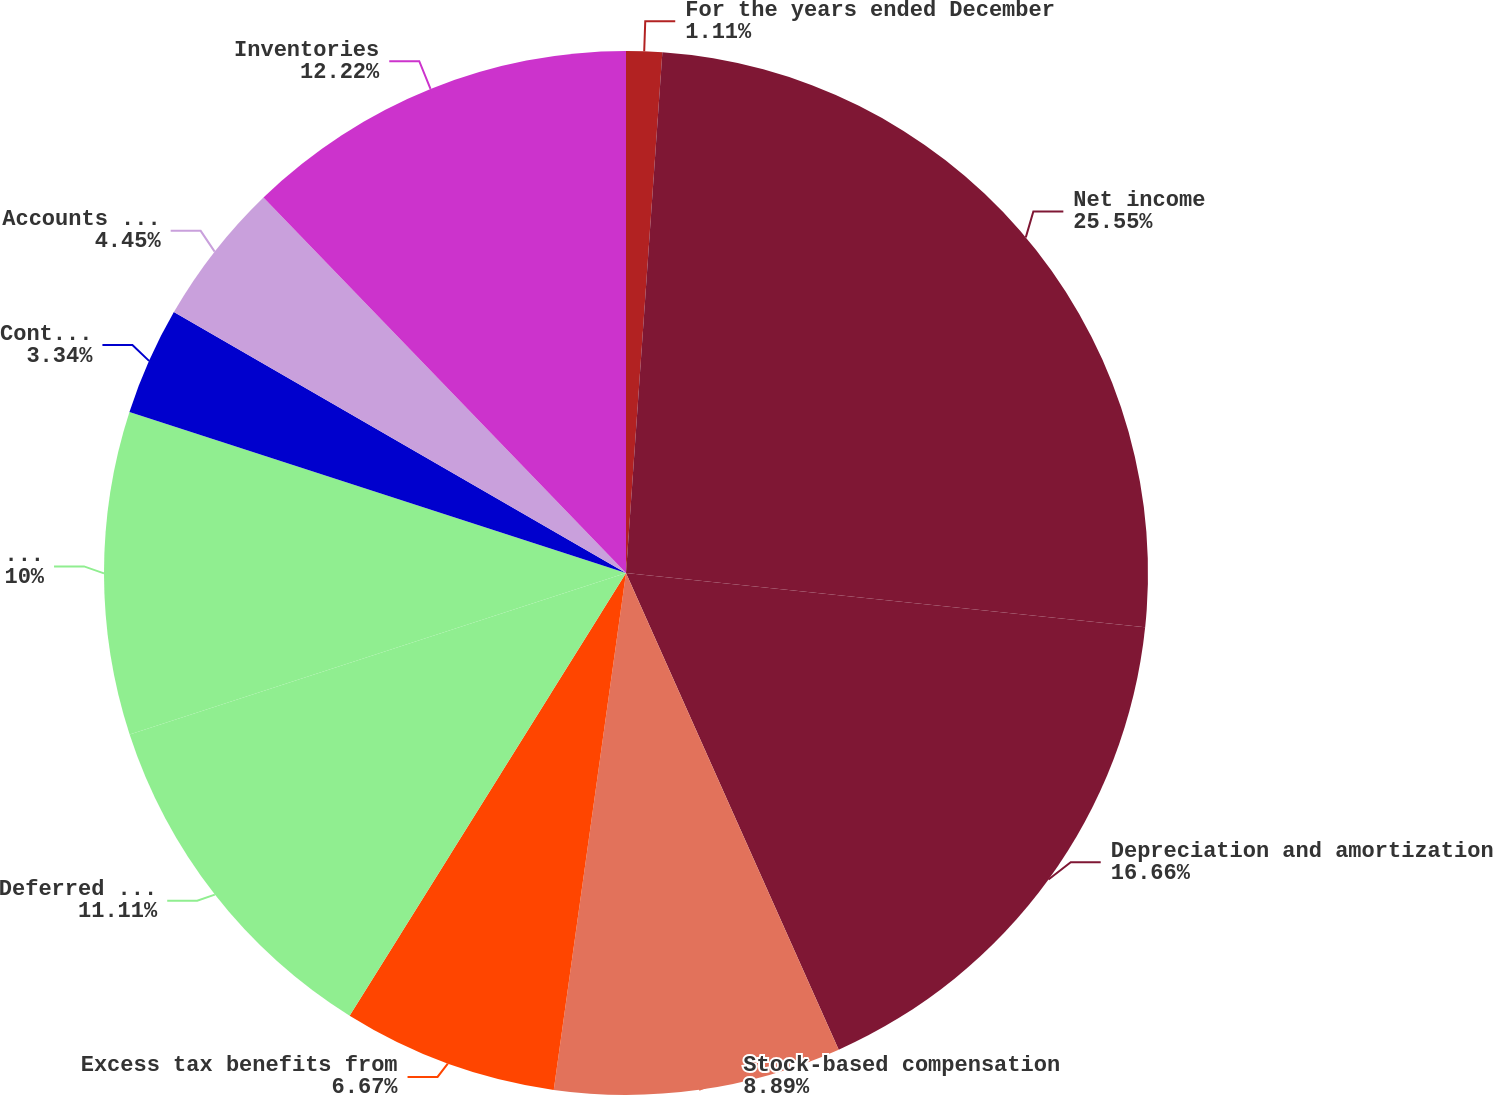Convert chart to OTSL. <chart><loc_0><loc_0><loc_500><loc_500><pie_chart><fcel>For the years ended December<fcel>Net income<fcel>Depreciation and amortization<fcel>Stock-based compensation<fcel>Excess tax benefits from<fcel>Deferred income taxes<fcel>Business realignment and<fcel>Contributions to pension plans<fcel>Accounts receivable-trade<fcel>Inventories<nl><fcel>1.11%<fcel>25.55%<fcel>16.66%<fcel>8.89%<fcel>6.67%<fcel>11.11%<fcel>10.0%<fcel>3.34%<fcel>4.45%<fcel>12.22%<nl></chart> 